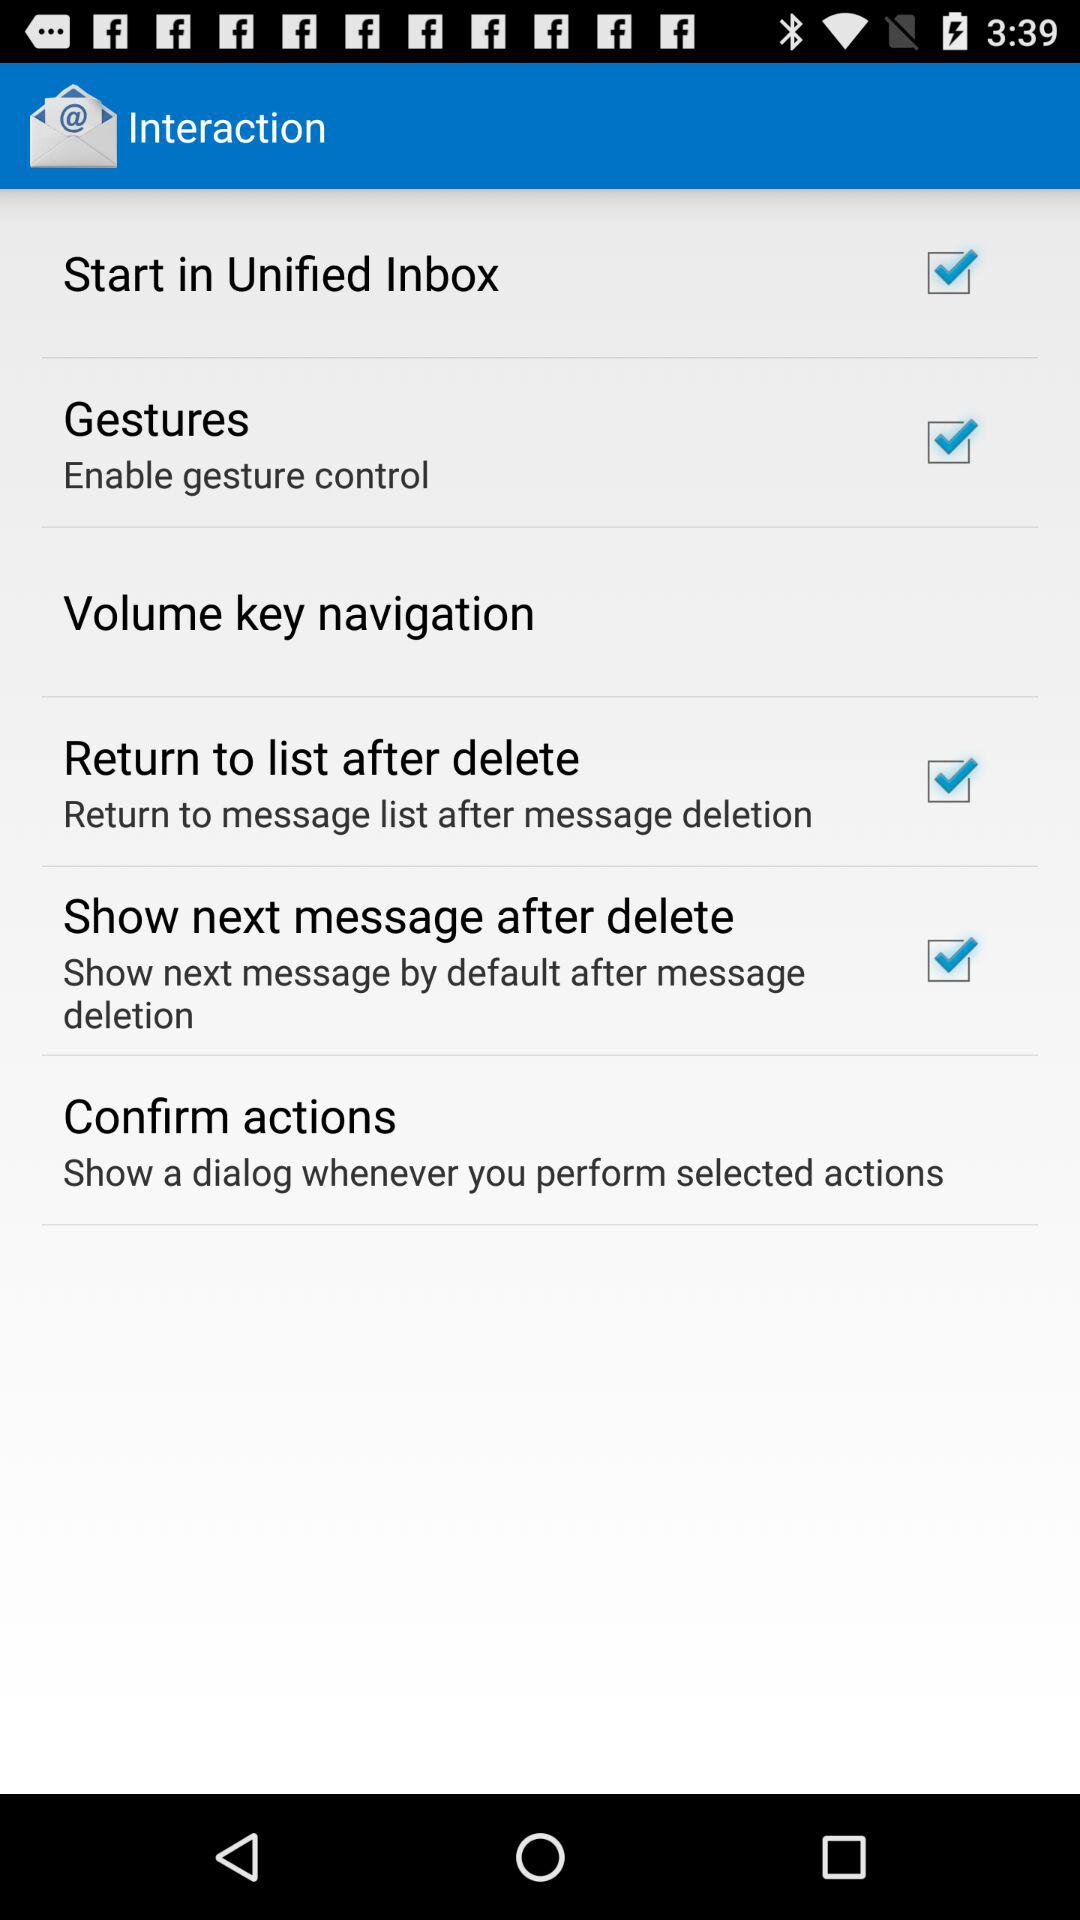Is "Return to list after delete" checked or unchecked? "Return to list after delete" is checked. 